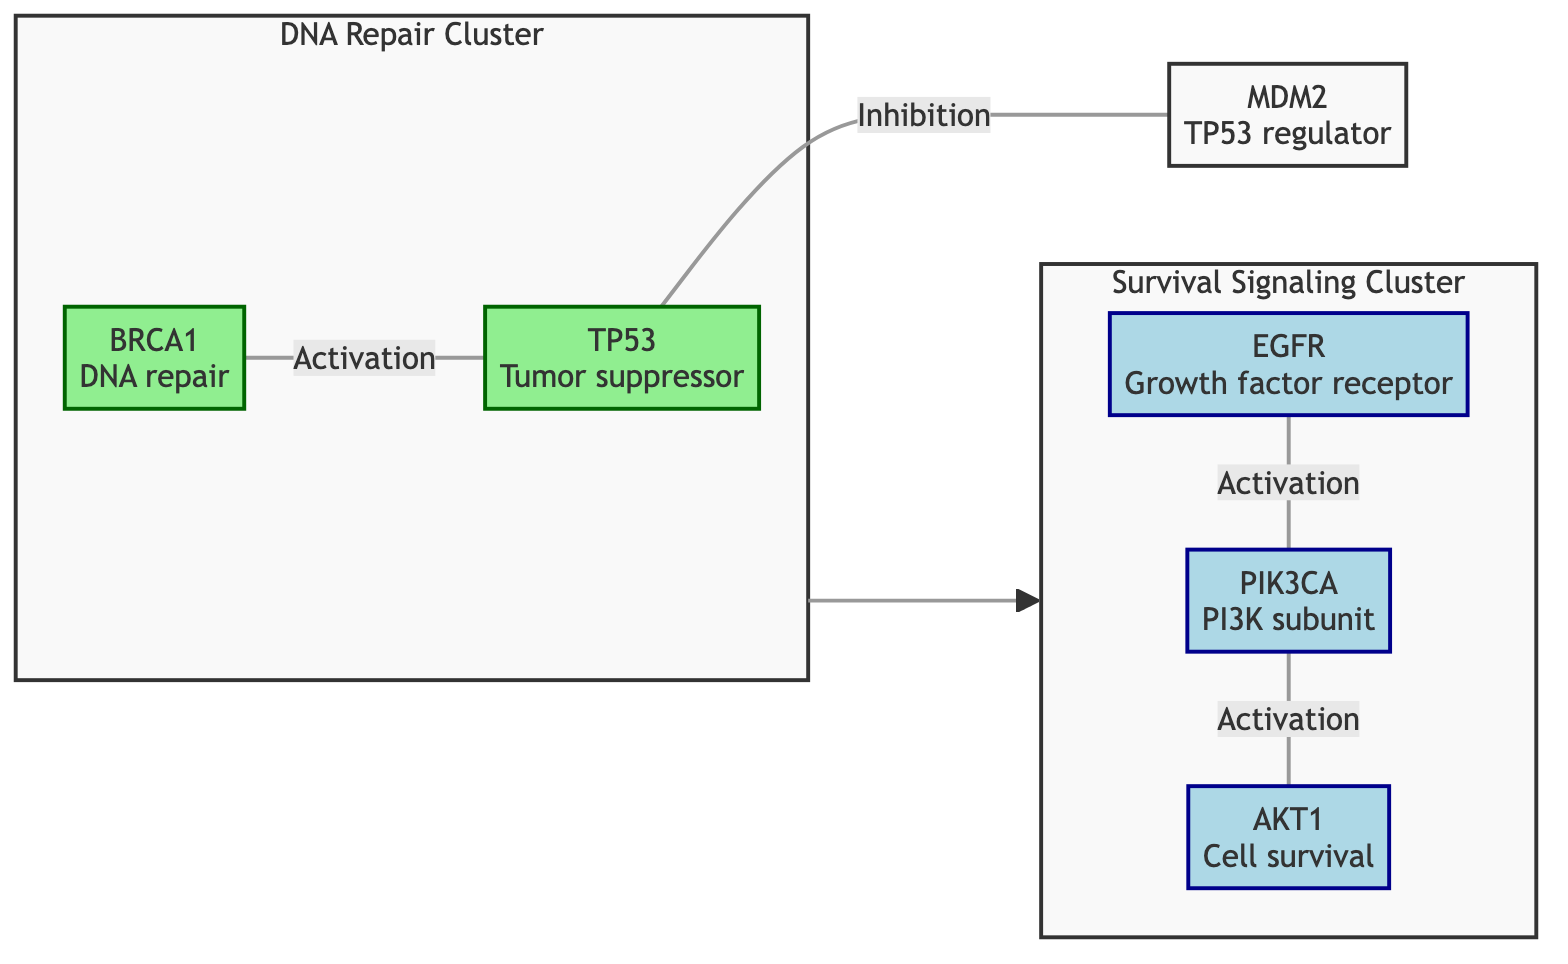What are the key hub proteins in this interaction network? The diagram indicates that the hub proteins are highlighted in a distinct color (gold). The nodes labeled as TP53 and EGFR receive this designation.
Answer: TP53, EGFR How many nodes are present in the network? By counting each distinct protein or node included in the diagram, we determine there are six nodes: TP53, BRCA1, MDM2, AKT1, EGFR, and PIK3CA.
Answer: 6 What type of interaction exists between P53 and MDM2? The diagram specifies a direction for the interaction, illustrating that P53 inhibits MDM2.
Answer: Inhibition Which cluster includes BRCA1? The visual representation groups BRCA1 with TP53 under the DNA Repair Cluster, indicating their association within that category.
Answer: DNA Repair Cluster What proteins are part of the Survival Signaling Cluster? The elements within the Survival Signaling Cluster are identified in the diagram, namely PIK3CA, AKT1, and EGFR, demonstrating their collective relation to survival signaling.
Answer: PIK3CA, AKT1, EGFR Which protein is regulated by MDM2? According to the depicted flow of interactions, MDM2 is shown as a regulator for TP53, indicating its role in this specific regulation.
Answer: TP53 Describe the interaction type involving PIK3CA and AKT1. The diagram indicates that PIK3CA activates AKT1, meaning there is a direct functional relationship where PIK3CA promotes the activity or expression of AKT1.
Answer: Activation How does the DNA Repair Cluster interact with the Survival Signaling Cluster? The diagram visually connects these two clusters, indicating that there is an interaction between them, symbolized by a directional arrow pointing from the DNA Repair Cluster to the Survival Signaling Cluster.
Answer: Interaction What color represents the hub proteins in the diagram? The hub proteins are distinguished by a specific color in the legend, and they are marked in gold, highlighting their importance in the network.
Answer: Gold 